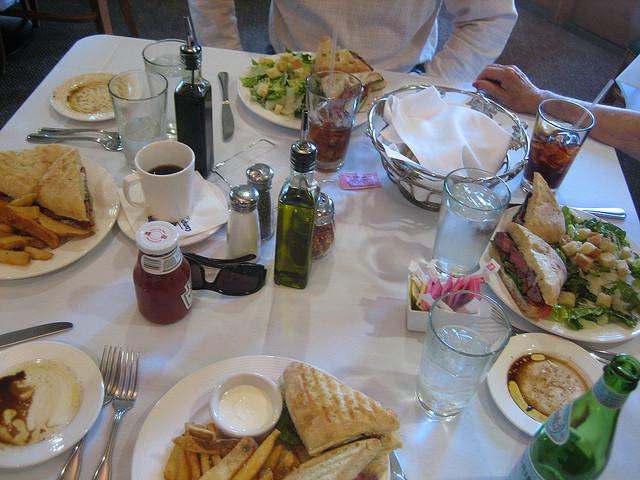How many baskets are on the table?
Keep it brief. 1. Is this a breakfast table?
Give a very brief answer. No. Is there a salad on one of the plates?
Concise answer only. Yes. How many plates of food are sitting on this white table?
Short answer required. 7. 